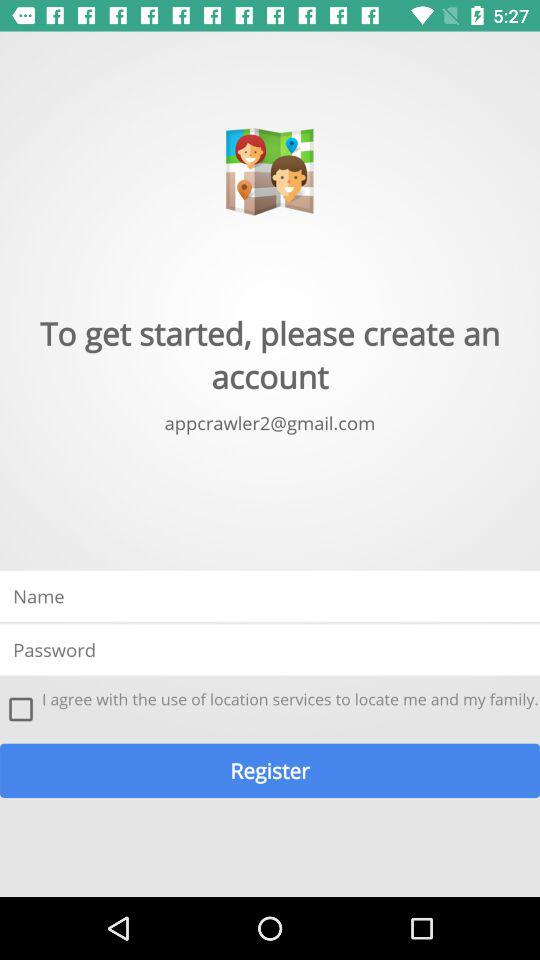What is the email address? The email address is appcrawler2@gmail.com. 